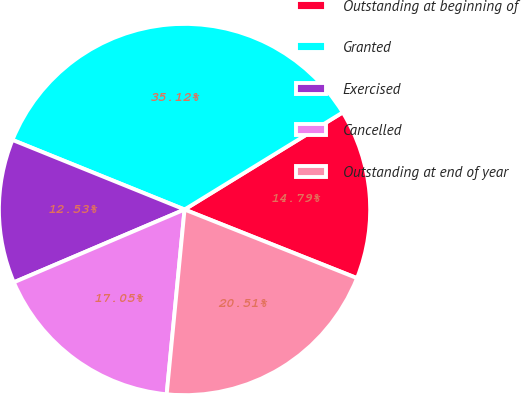Convert chart to OTSL. <chart><loc_0><loc_0><loc_500><loc_500><pie_chart><fcel>Outstanding at beginning of<fcel>Granted<fcel>Exercised<fcel>Cancelled<fcel>Outstanding at end of year<nl><fcel>14.79%<fcel>35.12%<fcel>12.53%<fcel>17.05%<fcel>20.51%<nl></chart> 